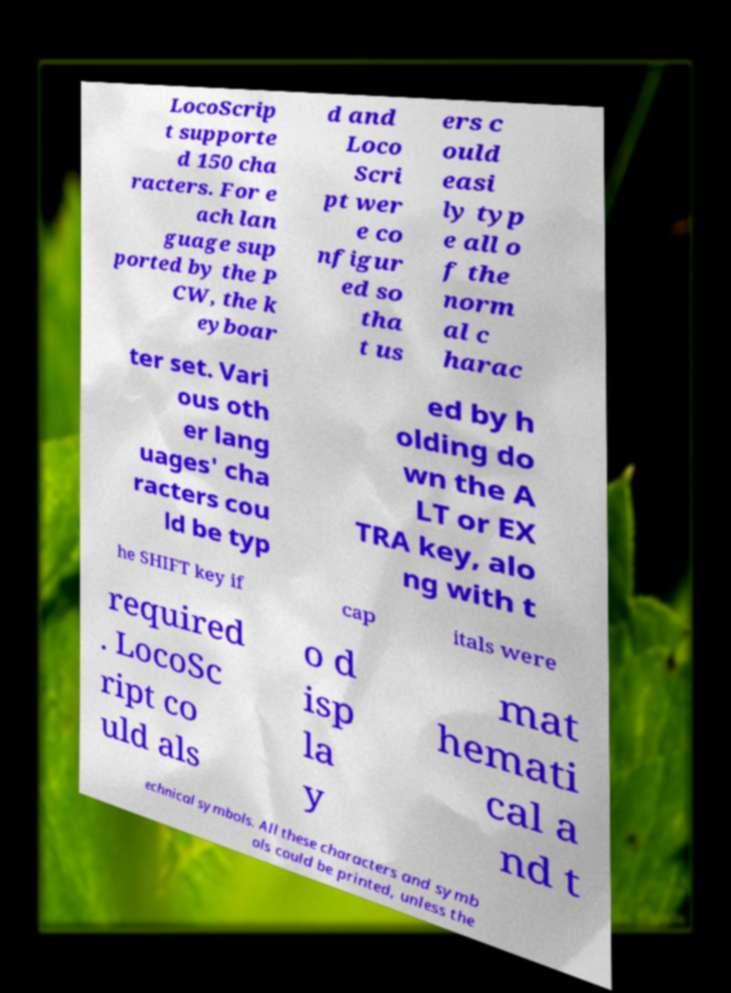For documentation purposes, I need the text within this image transcribed. Could you provide that? LocoScrip t supporte d 150 cha racters. For e ach lan guage sup ported by the P CW, the k eyboar d and Loco Scri pt wer e co nfigur ed so tha t us ers c ould easi ly typ e all o f the norm al c harac ter set. Vari ous oth er lang uages' cha racters cou ld be typ ed by h olding do wn the A LT or EX TRA key, alo ng with t he SHIFT key if cap itals were required . LocoSc ript co uld als o d isp la y mat hemati cal a nd t echnical symbols. All these characters and symb ols could be printed, unless the 